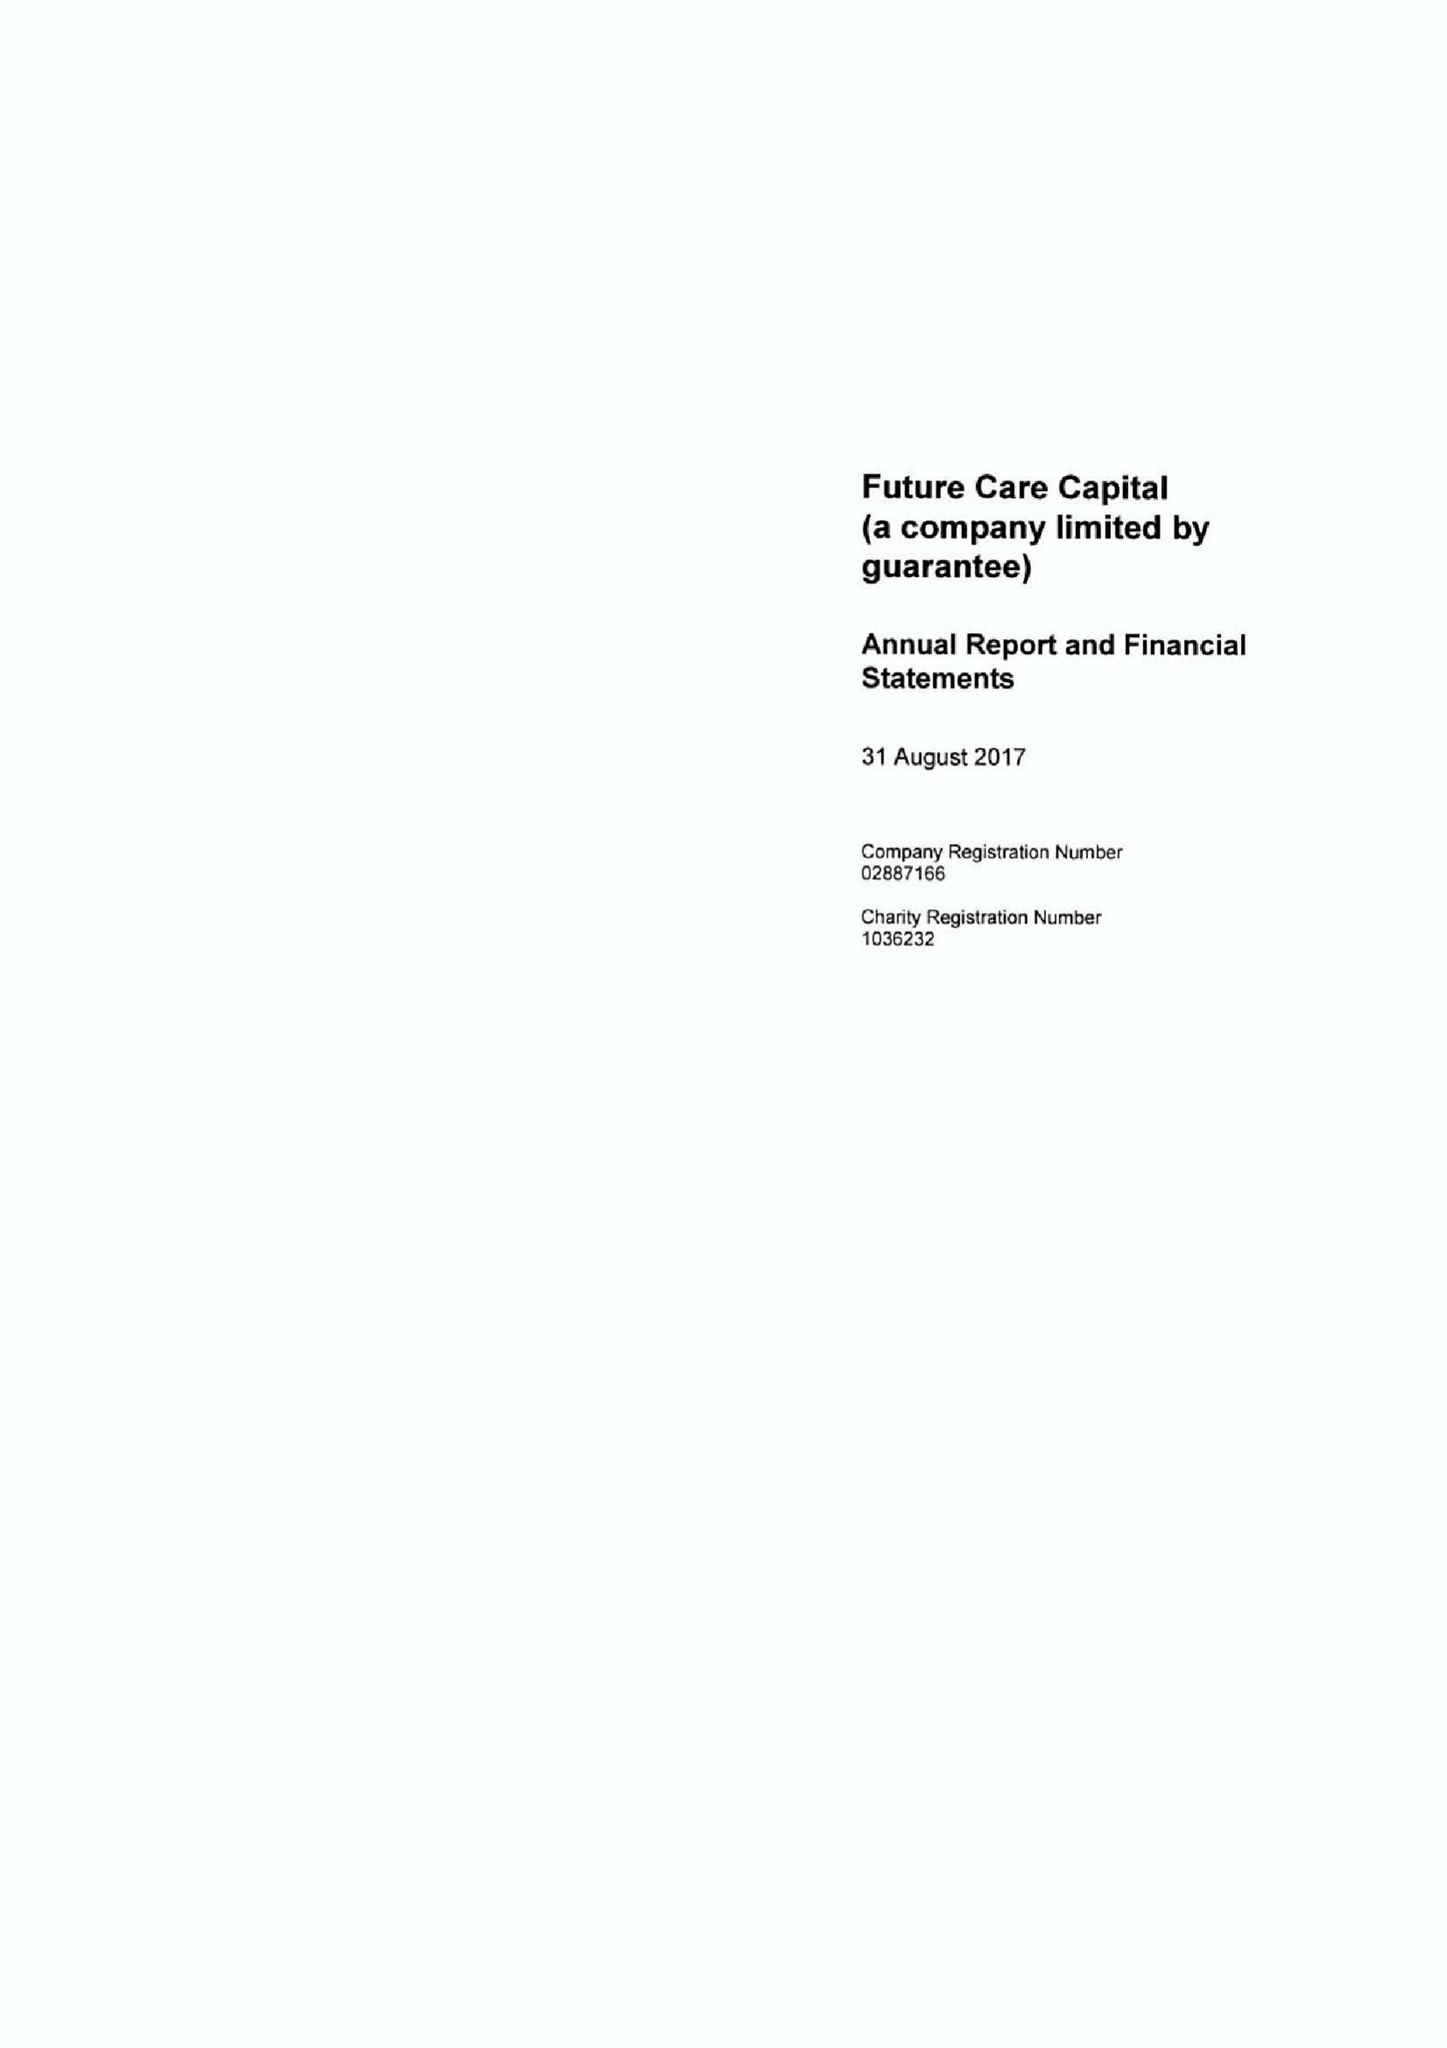What is the value for the income_annually_in_british_pounds?
Answer the question using a single word or phrase. 298000.00 